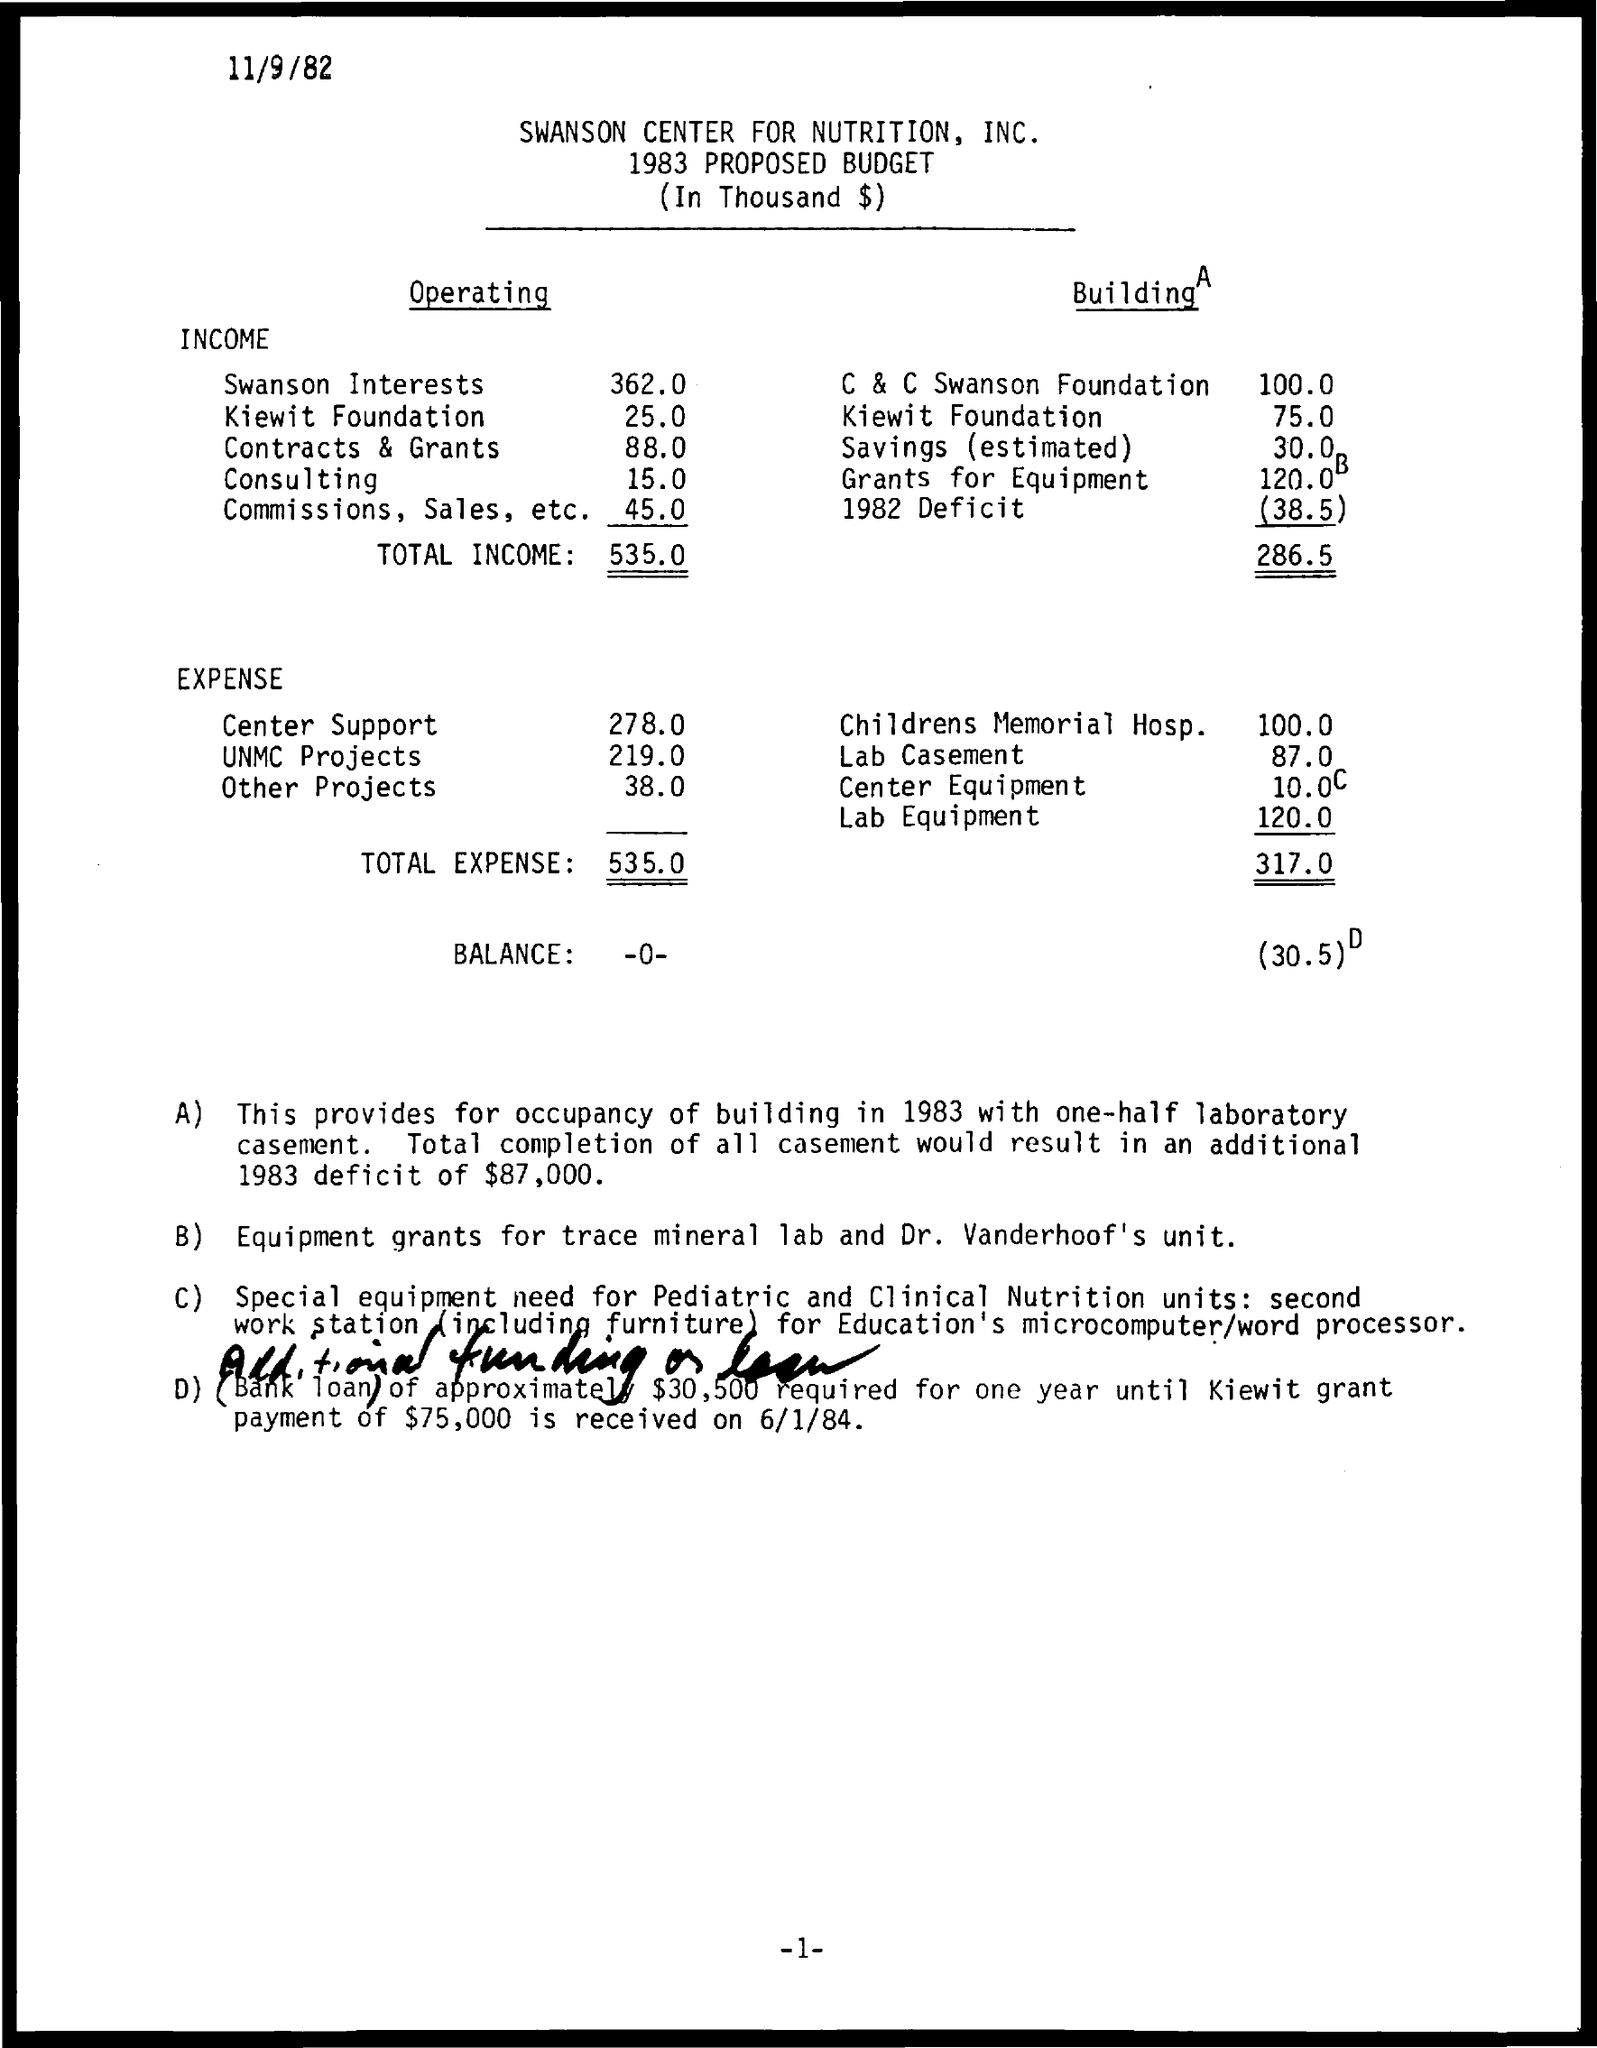Point out several critical features in this image. The second subheading under the heading 'Operating Expenses' is... Income is the first subheading under the heading 'Operating'. The "CENTER FOR NUTRITION" is known as the "Swanson Center for Nutrition, Inc. The Kiewit Foundation's operating income is $25.00. The expense referred to as "Center Support" is 278.0. 